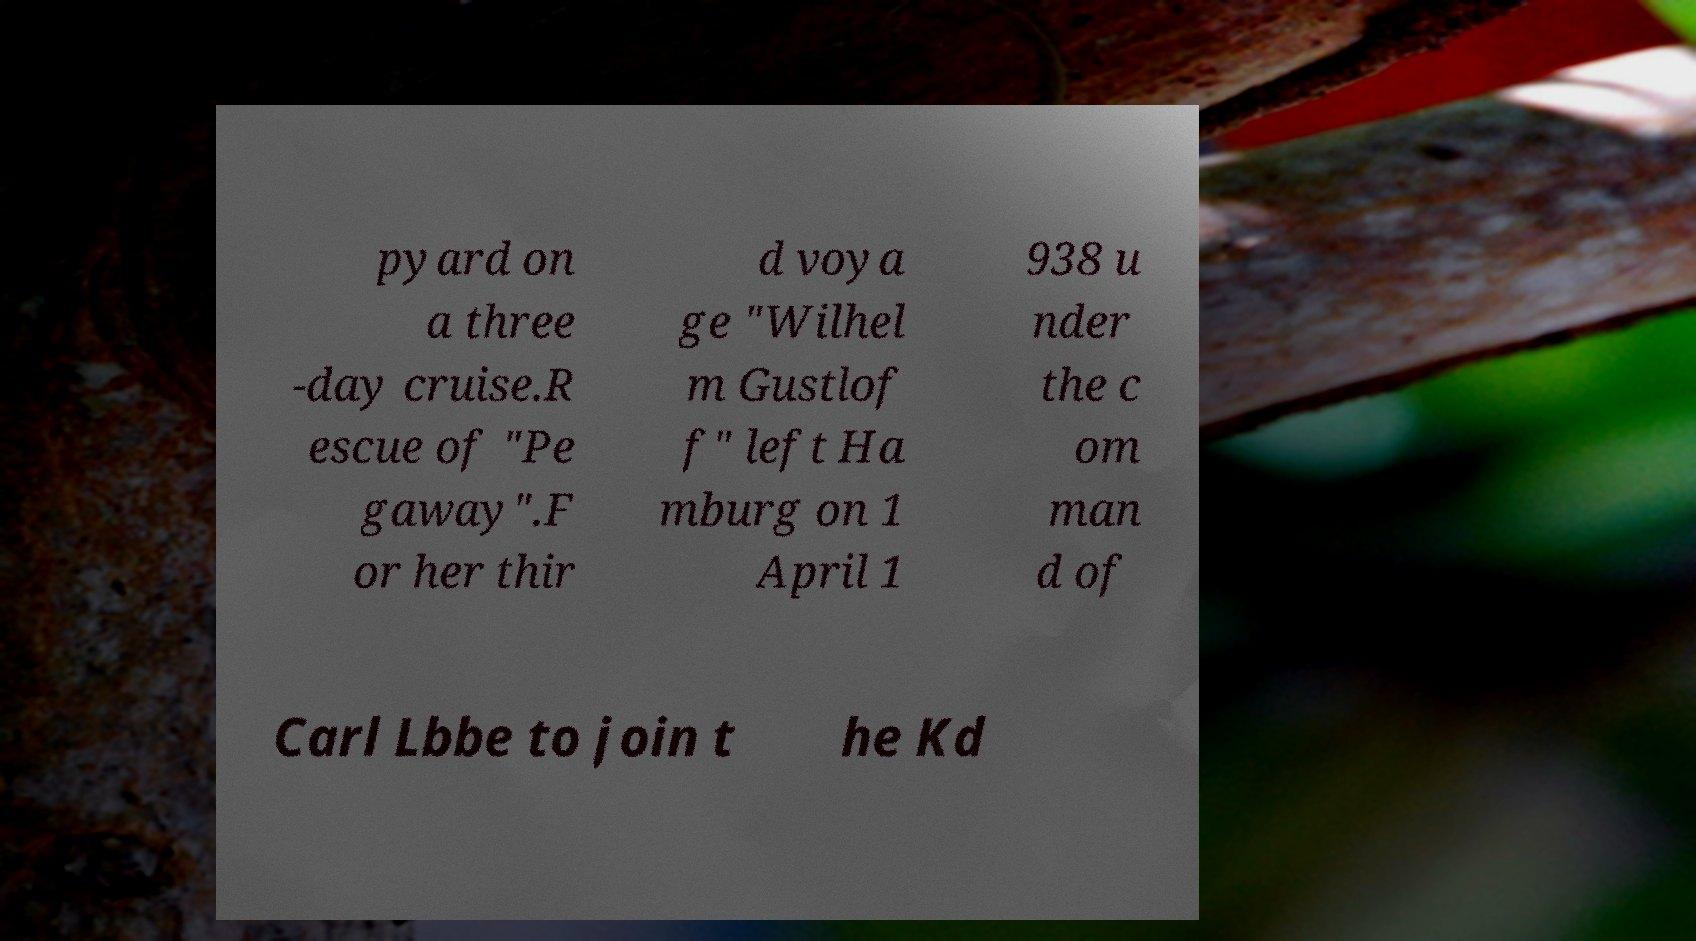Can you read and provide the text displayed in the image?This photo seems to have some interesting text. Can you extract and type it out for me? pyard on a three -day cruise.R escue of "Pe gaway".F or her thir d voya ge "Wilhel m Gustlof f" left Ha mburg on 1 April 1 938 u nder the c om man d of Carl Lbbe to join t he Kd 